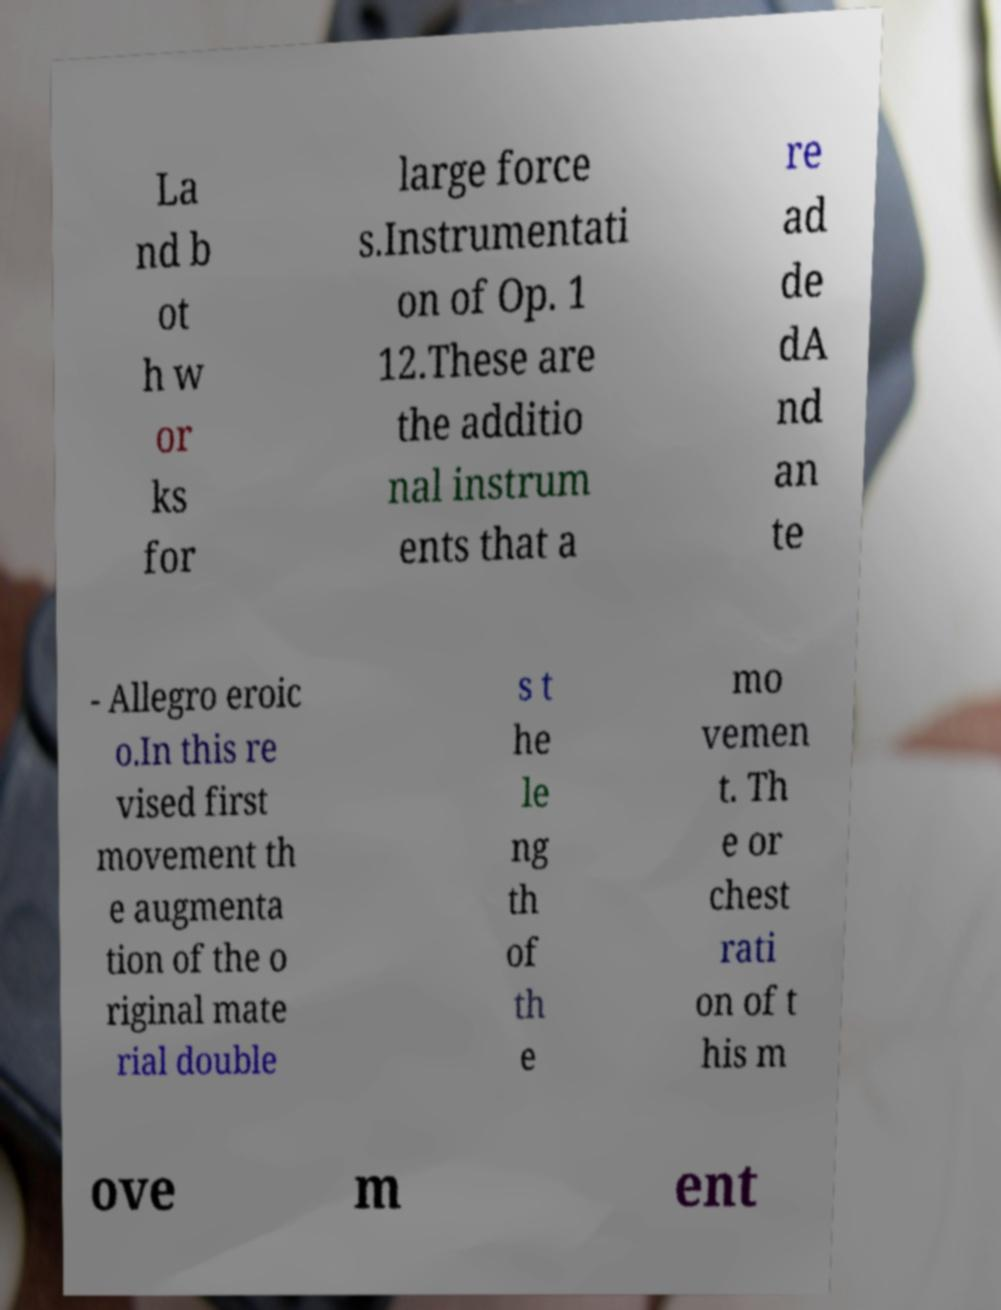Please read and relay the text visible in this image. What does it say? La nd b ot h w or ks for large force s.Instrumentati on of Op. 1 12.These are the additio nal instrum ents that a re ad de dA nd an te - Allegro eroic o.In this re vised first movement th e augmenta tion of the o riginal mate rial double s t he le ng th of th e mo vemen t. Th e or chest rati on of t his m ove m ent 